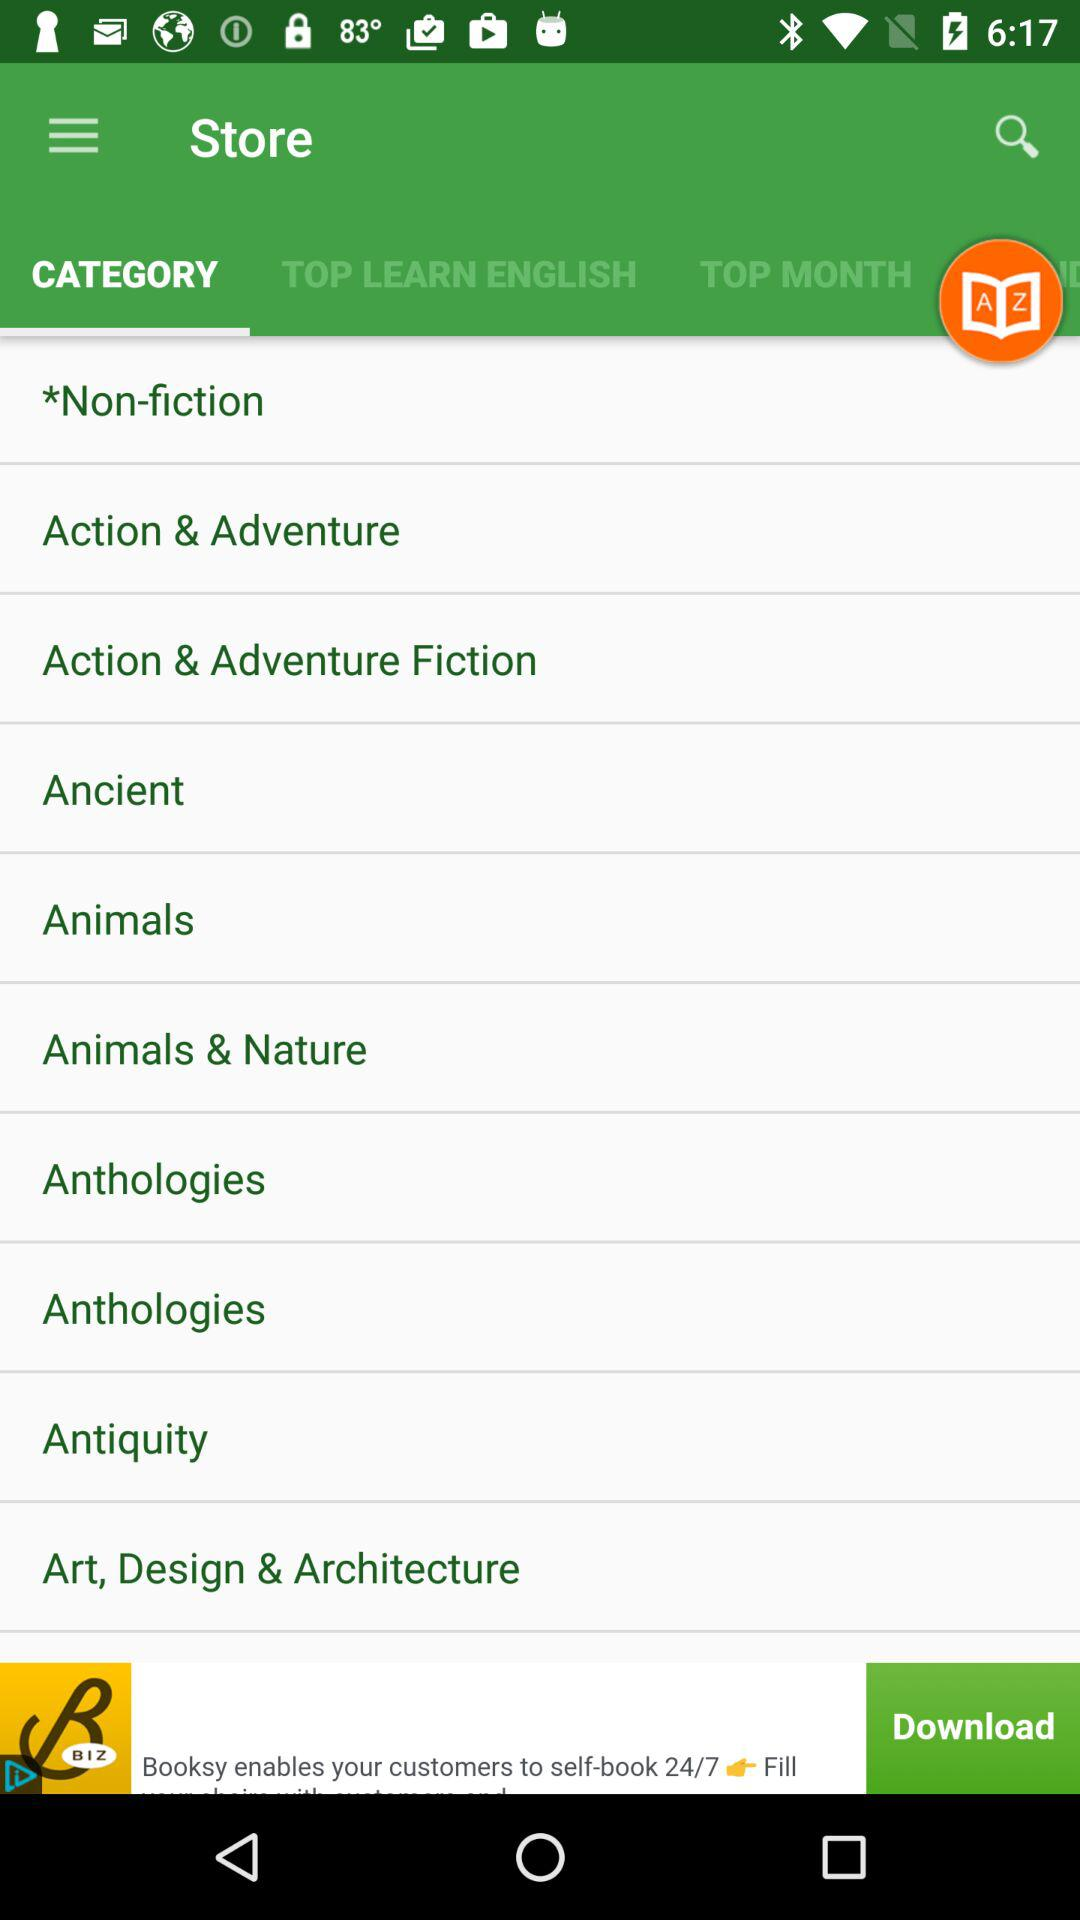Which tab am I on? You are on the "CATEGORY" tab. 